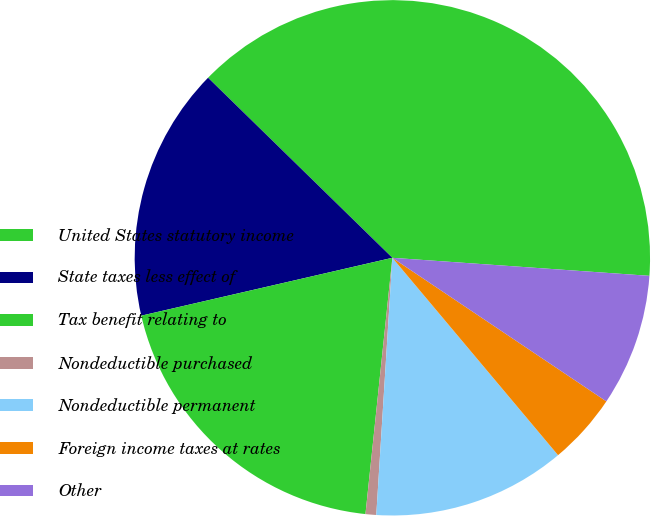Convert chart to OTSL. <chart><loc_0><loc_0><loc_500><loc_500><pie_chart><fcel>United States statutory income<fcel>State taxes less effect of<fcel>Tax benefit relating to<fcel>Nondeductible purchased<fcel>Nondeductible permanent<fcel>Foreign income taxes at rates<fcel>Other<nl><fcel>38.8%<fcel>15.92%<fcel>19.73%<fcel>0.67%<fcel>12.11%<fcel>4.48%<fcel>8.29%<nl></chart> 